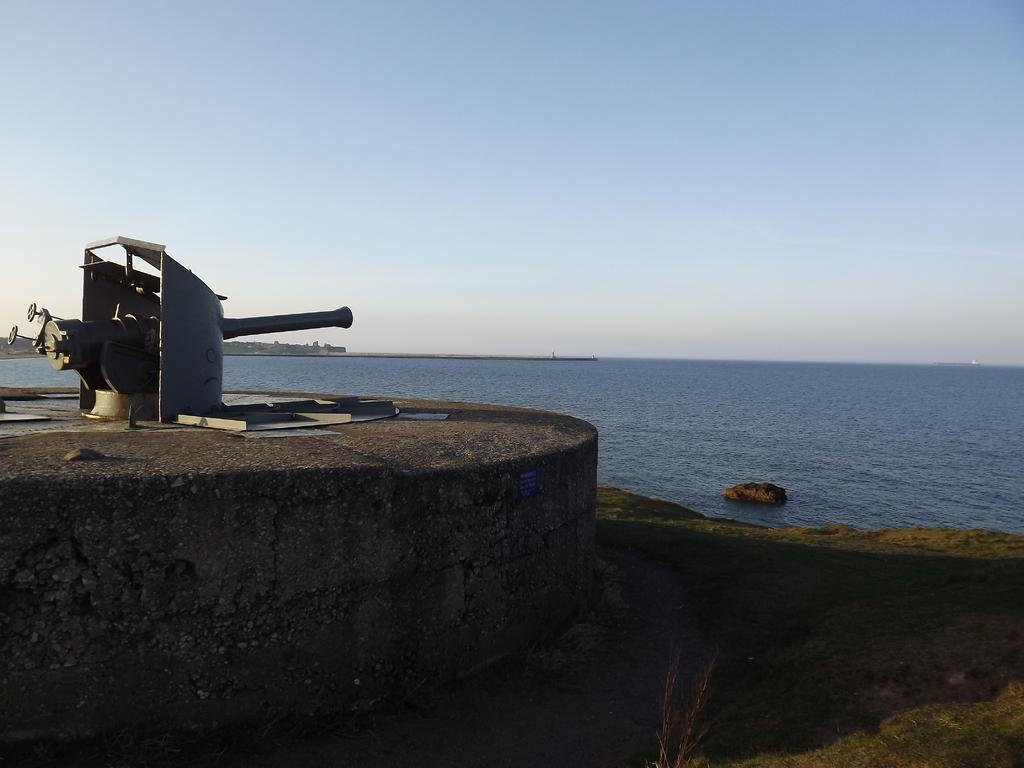What is located on the left side of the image? There is a machine on the left side of the image. What is the machine resting on? The machine is on a rock structure. What can be seen in the background of the image? There is a river and the sky visible in the background of the image. Can you see the partner of the machine in the image? There is no mention of a partner for the machine in the image, so it cannot be determined from the image. 